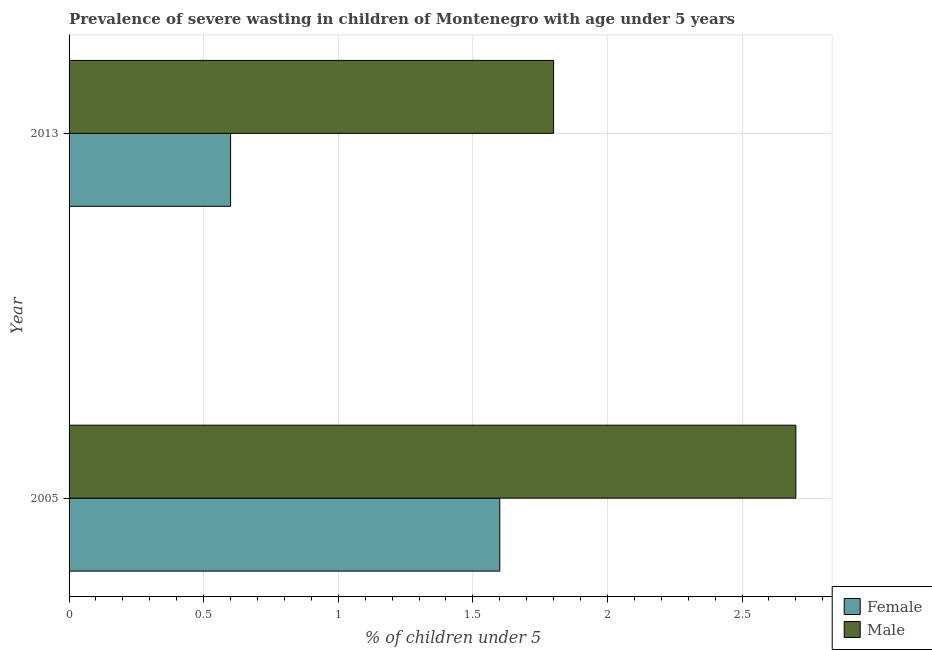Are the number of bars per tick equal to the number of legend labels?
Your answer should be very brief. Yes. How many bars are there on the 1st tick from the bottom?
Your answer should be very brief. 2. What is the label of the 1st group of bars from the top?
Keep it short and to the point. 2013. What is the percentage of undernourished male children in 2005?
Your answer should be compact. 2.7. Across all years, what is the maximum percentage of undernourished male children?
Your answer should be compact. 2.7. Across all years, what is the minimum percentage of undernourished female children?
Your answer should be compact. 0.6. In which year was the percentage of undernourished male children maximum?
Offer a very short reply. 2005. In which year was the percentage of undernourished female children minimum?
Give a very brief answer. 2013. What is the total percentage of undernourished female children in the graph?
Provide a succinct answer. 2.2. What is the difference between the percentage of undernourished female children in 2005 and the percentage of undernourished male children in 2013?
Your answer should be very brief. -0.2. What is the average percentage of undernourished male children per year?
Offer a very short reply. 2.25. In how many years, is the percentage of undernourished male children greater than 1.4 %?
Give a very brief answer. 2. What is the ratio of the percentage of undernourished female children in 2005 to that in 2013?
Ensure brevity in your answer.  2.67. What does the 1st bar from the top in 2005 represents?
Your answer should be very brief. Male. What does the 1st bar from the bottom in 2013 represents?
Your answer should be very brief. Female. How many years are there in the graph?
Your response must be concise. 2. What is the difference between two consecutive major ticks on the X-axis?
Your response must be concise. 0.5. Does the graph contain grids?
Offer a terse response. Yes. How many legend labels are there?
Make the answer very short. 2. What is the title of the graph?
Provide a succinct answer. Prevalence of severe wasting in children of Montenegro with age under 5 years. Does "Urban Population" appear as one of the legend labels in the graph?
Your answer should be compact. No. What is the label or title of the X-axis?
Your response must be concise.  % of children under 5. What is the label or title of the Y-axis?
Make the answer very short. Year. What is the  % of children under 5 of Female in 2005?
Your response must be concise. 1.6. What is the  % of children under 5 of Male in 2005?
Provide a short and direct response. 2.7. What is the  % of children under 5 of Female in 2013?
Your answer should be very brief. 0.6. What is the  % of children under 5 of Male in 2013?
Make the answer very short. 1.8. Across all years, what is the maximum  % of children under 5 in Female?
Keep it short and to the point. 1.6. Across all years, what is the maximum  % of children under 5 of Male?
Make the answer very short. 2.7. Across all years, what is the minimum  % of children under 5 of Female?
Keep it short and to the point. 0.6. Across all years, what is the minimum  % of children under 5 in Male?
Your answer should be compact. 1.8. What is the total  % of children under 5 in Male in the graph?
Give a very brief answer. 4.5. What is the difference between the  % of children under 5 of Female in 2005 and the  % of children under 5 of Male in 2013?
Your answer should be very brief. -0.2. What is the average  % of children under 5 in Female per year?
Offer a terse response. 1.1. What is the average  % of children under 5 of Male per year?
Offer a very short reply. 2.25. In the year 2013, what is the difference between the  % of children under 5 in Female and  % of children under 5 in Male?
Your answer should be compact. -1.2. What is the ratio of the  % of children under 5 of Female in 2005 to that in 2013?
Keep it short and to the point. 2.67. What is the difference between the highest and the lowest  % of children under 5 of Female?
Keep it short and to the point. 1. What is the difference between the highest and the lowest  % of children under 5 of Male?
Provide a short and direct response. 0.9. 